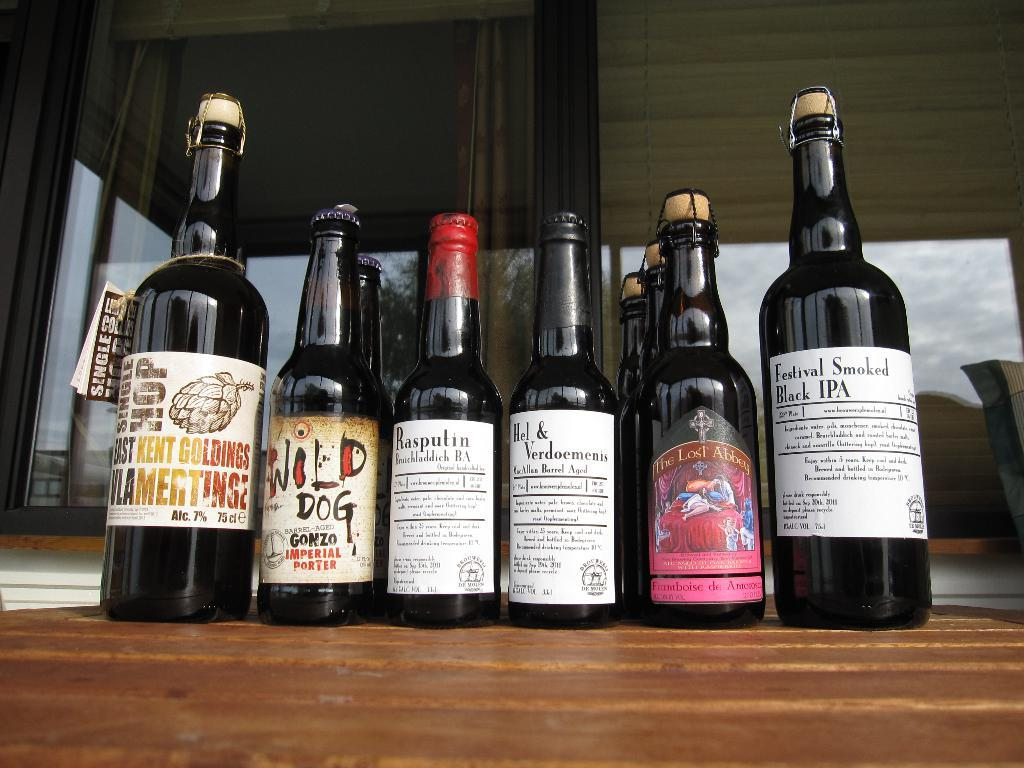<image>
Give a short and clear explanation of the subsequent image. the word dog is on the front of a bottle 